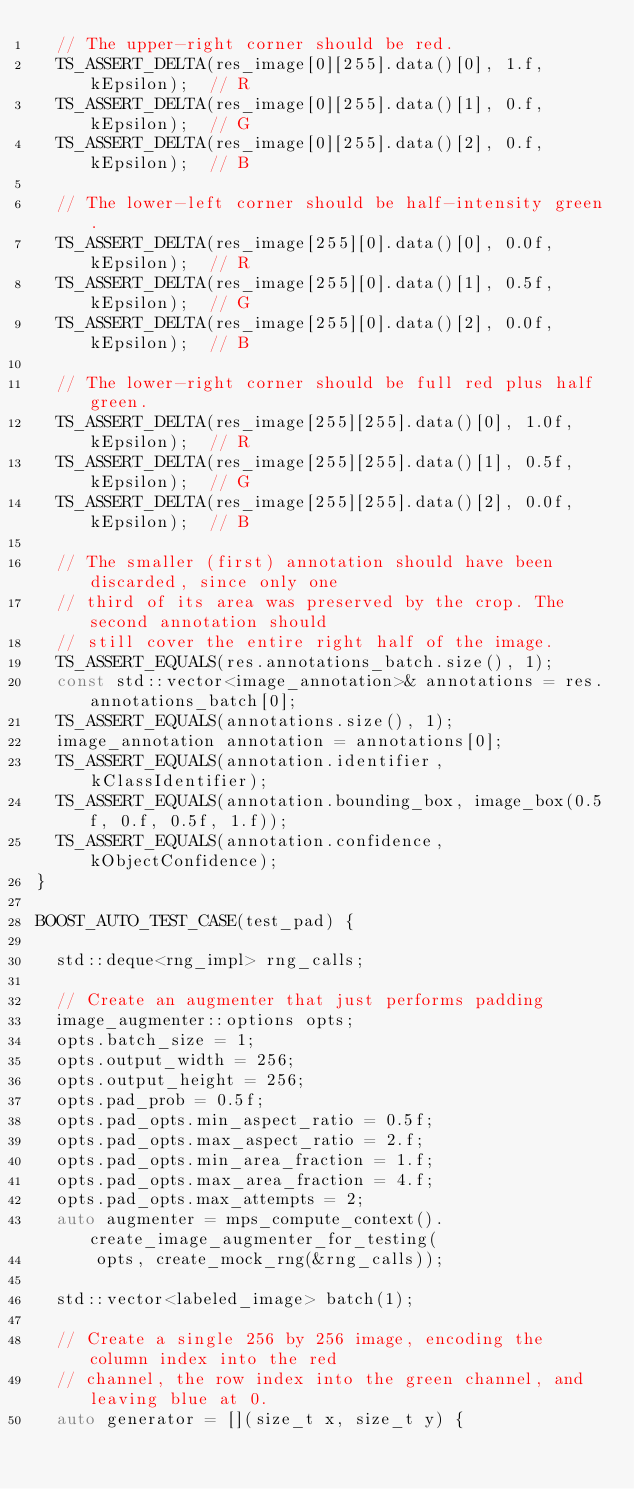Convert code to text. <code><loc_0><loc_0><loc_500><loc_500><_C++_>  // The upper-right corner should be red.
  TS_ASSERT_DELTA(res_image[0][255].data()[0], 1.f, kEpsilon);  // R
  TS_ASSERT_DELTA(res_image[0][255].data()[1], 0.f, kEpsilon);  // G
  TS_ASSERT_DELTA(res_image[0][255].data()[2], 0.f, kEpsilon);  // B

  // The lower-left corner should be half-intensity green.
  TS_ASSERT_DELTA(res_image[255][0].data()[0], 0.0f, kEpsilon);  // R
  TS_ASSERT_DELTA(res_image[255][0].data()[1], 0.5f, kEpsilon);  // G
  TS_ASSERT_DELTA(res_image[255][0].data()[2], 0.0f, kEpsilon);  // B

  // The lower-right corner should be full red plus half green.
  TS_ASSERT_DELTA(res_image[255][255].data()[0], 1.0f, kEpsilon);  // R
  TS_ASSERT_DELTA(res_image[255][255].data()[1], 0.5f, kEpsilon);  // G
  TS_ASSERT_DELTA(res_image[255][255].data()[2], 0.0f, kEpsilon);  // B

  // The smaller (first) annotation should have been discarded, since only one
  // third of its area was preserved by the crop. The second annotation should
  // still cover the entire right half of the image.
  TS_ASSERT_EQUALS(res.annotations_batch.size(), 1);
  const std::vector<image_annotation>& annotations = res.annotations_batch[0];
  TS_ASSERT_EQUALS(annotations.size(), 1);
  image_annotation annotation = annotations[0];
  TS_ASSERT_EQUALS(annotation.identifier, kClassIdentifier);
  TS_ASSERT_EQUALS(annotation.bounding_box, image_box(0.5f, 0.f, 0.5f, 1.f));
  TS_ASSERT_EQUALS(annotation.confidence, kObjectConfidence);
}

BOOST_AUTO_TEST_CASE(test_pad) {

  std::deque<rng_impl> rng_calls;

  // Create an augmenter that just performs padding
  image_augmenter::options opts;
  opts.batch_size = 1;
  opts.output_width = 256;
  opts.output_height = 256;
  opts.pad_prob = 0.5f;
  opts.pad_opts.min_aspect_ratio = 0.5f;
  opts.pad_opts.max_aspect_ratio = 2.f;
  opts.pad_opts.min_area_fraction = 1.f;
  opts.pad_opts.max_area_fraction = 4.f;
  opts.pad_opts.max_attempts = 2;
  auto augmenter = mps_compute_context().create_image_augmenter_for_testing(
      opts, create_mock_rng(&rng_calls));

  std::vector<labeled_image> batch(1);

  // Create a single 256 by 256 image, encoding the column index into the red
  // channel, the row index into the green channel, and leaving blue at 0.
  auto generator = [](size_t x, size_t y) {</code> 